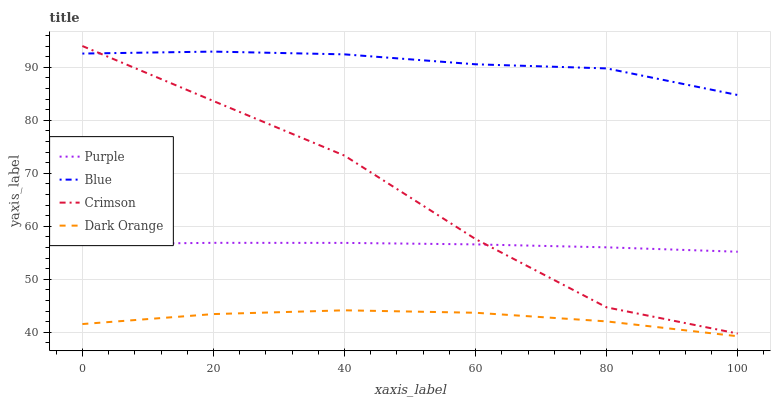Does Dark Orange have the minimum area under the curve?
Answer yes or no. Yes. Does Blue have the maximum area under the curve?
Answer yes or no. Yes. Does Crimson have the minimum area under the curve?
Answer yes or no. No. Does Crimson have the maximum area under the curve?
Answer yes or no. No. Is Purple the smoothest?
Answer yes or no. Yes. Is Crimson the roughest?
Answer yes or no. Yes. Is Blue the smoothest?
Answer yes or no. No. Is Blue the roughest?
Answer yes or no. No. Does Dark Orange have the lowest value?
Answer yes or no. Yes. Does Crimson have the lowest value?
Answer yes or no. No. Does Crimson have the highest value?
Answer yes or no. Yes. Does Blue have the highest value?
Answer yes or no. No. Is Dark Orange less than Crimson?
Answer yes or no. Yes. Is Blue greater than Purple?
Answer yes or no. Yes. Does Blue intersect Crimson?
Answer yes or no. Yes. Is Blue less than Crimson?
Answer yes or no. No. Is Blue greater than Crimson?
Answer yes or no. No. Does Dark Orange intersect Crimson?
Answer yes or no. No. 